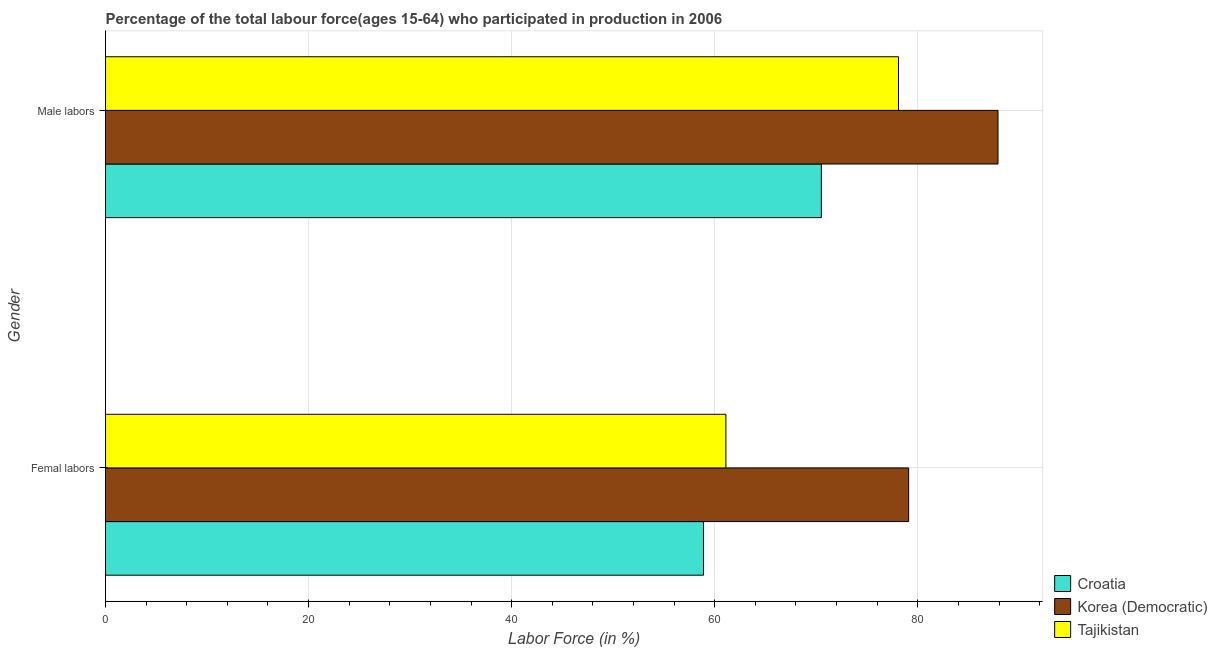How many groups of bars are there?
Ensure brevity in your answer.  2. Are the number of bars on each tick of the Y-axis equal?
Offer a very short reply. Yes. What is the label of the 2nd group of bars from the top?
Make the answer very short. Femal labors. What is the percentage of male labour force in Tajikistan?
Provide a succinct answer. 78.1. Across all countries, what is the maximum percentage of female labor force?
Provide a succinct answer. 79.1. Across all countries, what is the minimum percentage of female labor force?
Offer a terse response. 58.9. In which country was the percentage of female labor force maximum?
Make the answer very short. Korea (Democratic). In which country was the percentage of female labor force minimum?
Keep it short and to the point. Croatia. What is the total percentage of female labor force in the graph?
Ensure brevity in your answer.  199.1. What is the difference between the percentage of female labor force in Tajikistan and that in Croatia?
Keep it short and to the point. 2.2. What is the difference between the percentage of female labor force in Korea (Democratic) and the percentage of male labour force in Tajikistan?
Your answer should be very brief. 1. What is the average percentage of female labor force per country?
Give a very brief answer. 66.37. What is the difference between the percentage of male labour force and percentage of female labor force in Tajikistan?
Ensure brevity in your answer.  17. What is the ratio of the percentage of male labour force in Korea (Democratic) to that in Tajikistan?
Offer a very short reply. 1.13. What does the 1st bar from the top in Male labors represents?
Your answer should be compact. Tajikistan. What does the 2nd bar from the bottom in Femal labors represents?
Your response must be concise. Korea (Democratic). What is the difference between two consecutive major ticks on the X-axis?
Offer a terse response. 20. Are the values on the major ticks of X-axis written in scientific E-notation?
Provide a short and direct response. No. Does the graph contain any zero values?
Make the answer very short. No. How many legend labels are there?
Ensure brevity in your answer.  3. How are the legend labels stacked?
Provide a short and direct response. Vertical. What is the title of the graph?
Your answer should be very brief. Percentage of the total labour force(ages 15-64) who participated in production in 2006. Does "Cayman Islands" appear as one of the legend labels in the graph?
Give a very brief answer. No. What is the Labor Force (in %) in Croatia in Femal labors?
Offer a very short reply. 58.9. What is the Labor Force (in %) of Korea (Democratic) in Femal labors?
Your response must be concise. 79.1. What is the Labor Force (in %) in Tajikistan in Femal labors?
Provide a short and direct response. 61.1. What is the Labor Force (in %) of Croatia in Male labors?
Your response must be concise. 70.5. What is the Labor Force (in %) of Korea (Democratic) in Male labors?
Offer a terse response. 87.9. What is the Labor Force (in %) of Tajikistan in Male labors?
Give a very brief answer. 78.1. Across all Gender, what is the maximum Labor Force (in %) of Croatia?
Offer a very short reply. 70.5. Across all Gender, what is the maximum Labor Force (in %) of Korea (Democratic)?
Your answer should be very brief. 87.9. Across all Gender, what is the maximum Labor Force (in %) in Tajikistan?
Make the answer very short. 78.1. Across all Gender, what is the minimum Labor Force (in %) in Croatia?
Give a very brief answer. 58.9. Across all Gender, what is the minimum Labor Force (in %) of Korea (Democratic)?
Your answer should be compact. 79.1. Across all Gender, what is the minimum Labor Force (in %) in Tajikistan?
Your answer should be very brief. 61.1. What is the total Labor Force (in %) in Croatia in the graph?
Ensure brevity in your answer.  129.4. What is the total Labor Force (in %) in Korea (Democratic) in the graph?
Your answer should be compact. 167. What is the total Labor Force (in %) in Tajikistan in the graph?
Offer a very short reply. 139.2. What is the difference between the Labor Force (in %) of Croatia in Femal labors and that in Male labors?
Provide a succinct answer. -11.6. What is the difference between the Labor Force (in %) of Korea (Democratic) in Femal labors and that in Male labors?
Offer a very short reply. -8.8. What is the difference between the Labor Force (in %) of Croatia in Femal labors and the Labor Force (in %) of Tajikistan in Male labors?
Your response must be concise. -19.2. What is the difference between the Labor Force (in %) in Korea (Democratic) in Femal labors and the Labor Force (in %) in Tajikistan in Male labors?
Your response must be concise. 1. What is the average Labor Force (in %) of Croatia per Gender?
Provide a short and direct response. 64.7. What is the average Labor Force (in %) of Korea (Democratic) per Gender?
Your answer should be compact. 83.5. What is the average Labor Force (in %) of Tajikistan per Gender?
Your response must be concise. 69.6. What is the difference between the Labor Force (in %) of Croatia and Labor Force (in %) of Korea (Democratic) in Femal labors?
Provide a succinct answer. -20.2. What is the difference between the Labor Force (in %) of Croatia and Labor Force (in %) of Korea (Democratic) in Male labors?
Provide a succinct answer. -17.4. What is the difference between the Labor Force (in %) of Korea (Democratic) and Labor Force (in %) of Tajikistan in Male labors?
Provide a short and direct response. 9.8. What is the ratio of the Labor Force (in %) in Croatia in Femal labors to that in Male labors?
Provide a short and direct response. 0.84. What is the ratio of the Labor Force (in %) of Korea (Democratic) in Femal labors to that in Male labors?
Offer a terse response. 0.9. What is the ratio of the Labor Force (in %) in Tajikistan in Femal labors to that in Male labors?
Your answer should be very brief. 0.78. What is the difference between the highest and the second highest Labor Force (in %) of Croatia?
Your answer should be very brief. 11.6. What is the difference between the highest and the second highest Labor Force (in %) of Tajikistan?
Provide a short and direct response. 17. What is the difference between the highest and the lowest Labor Force (in %) of Korea (Democratic)?
Provide a short and direct response. 8.8. 